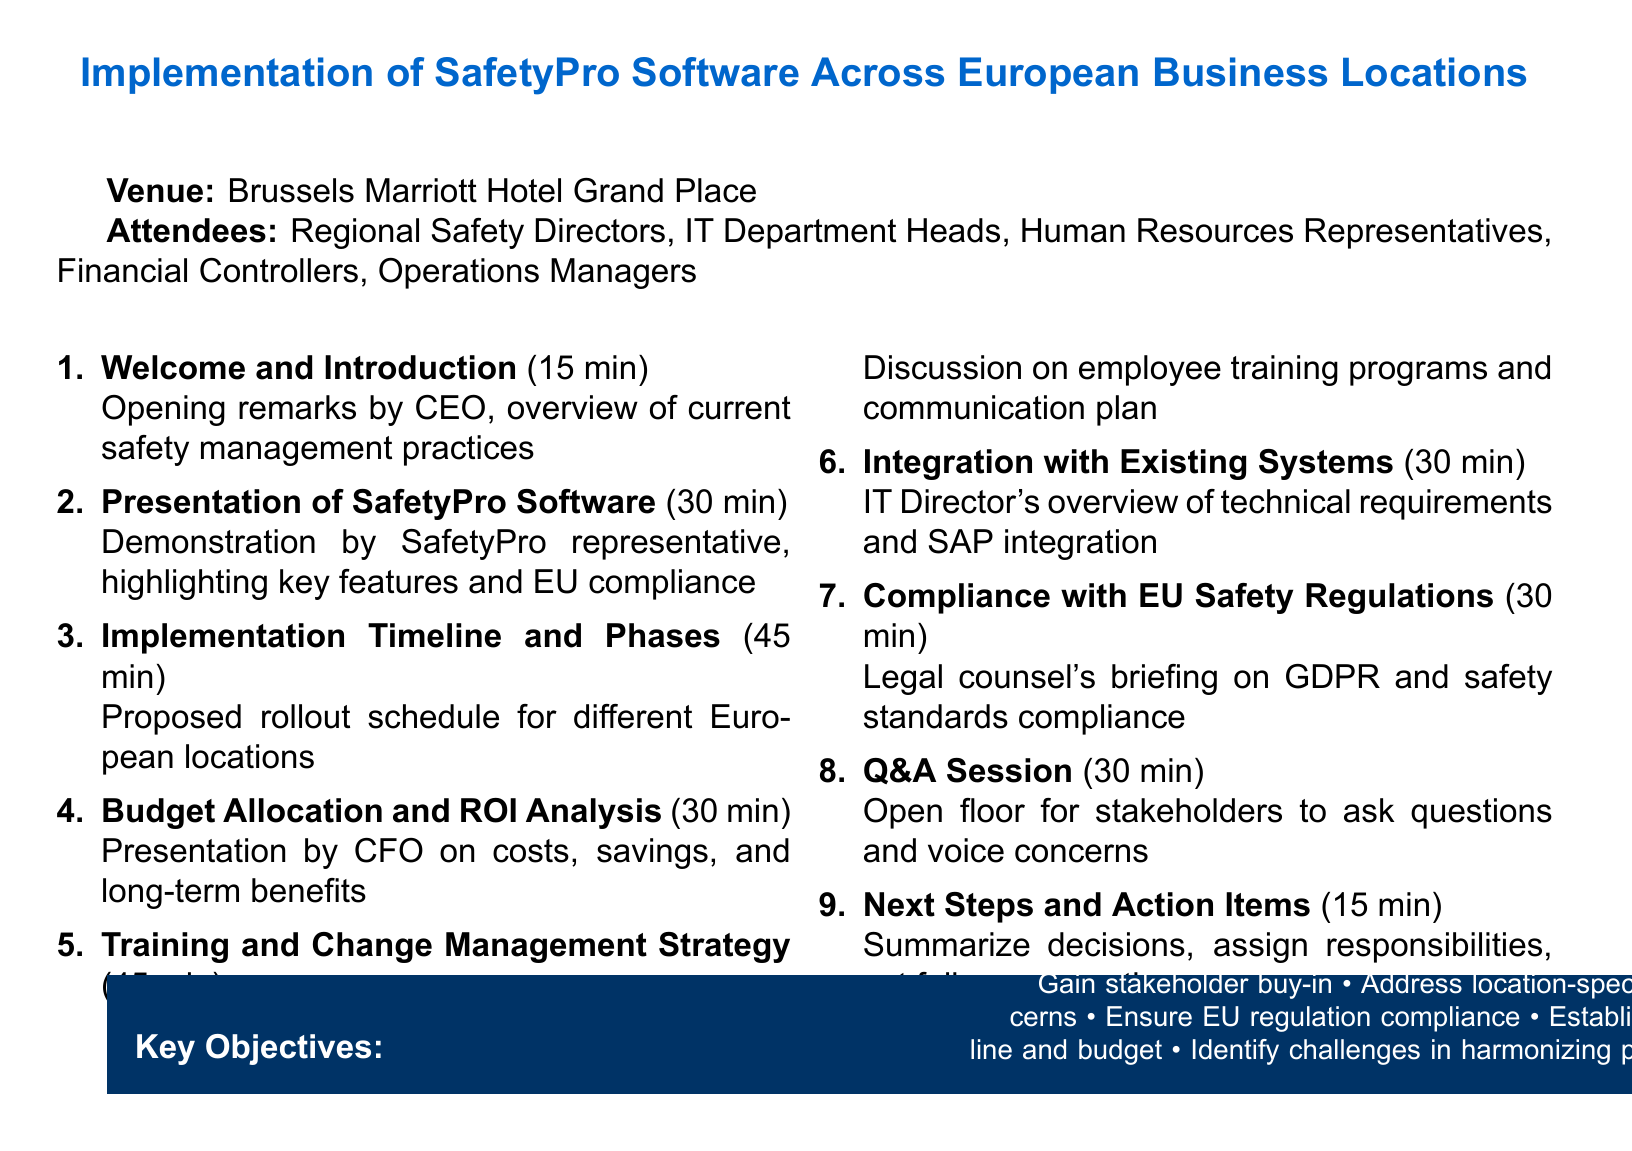What is the meeting title? The meeting title is specified in the document, indicating the main topic being discussed.
Answer: Stakeholder Meeting: Implementation of SafetyPro Software Across European Business Locations What is the date of the meeting? The date is explicitly mentioned in the document, providing a specific time for the event.
Answer: 15 June 2023 Where is the venue located? The venue's location is listed in the document, indicating where the meeting will be held.
Answer: Brussels Marriott Hotel Grand Place Who is responsible for the presentation of the SafetyPro Software? The document specifies who will lead the demo, giving clarity on responsibilities.
Answer: SafetyPro representative What is the duration for the Q&A Session? The document provides the time allocation for each agenda item, including this one.
Answer: 30 minutes How many minutes are allocated to the Training and Change Management Strategy? The document lists the duration for discussion on training and change management, providing clarity on time management.
Answer: 45 minutes What are the key objectives of the meeting? The document outlines the main goals, presenting a summary of what the meeting aims to achieve.
Answer: Gain stakeholder buy-in • Address location-specific concerns • Ensure EU regulation compliance • Establish timeline and budget • Identify challenges in harmonizing practices Who will lead the discussion on Budget Allocation and ROI Analysis? The agenda specifies who will present this topic, clarifying roles in the meeting.
Answer: CFO How many attendees are listed in the document? The document includes a list of attendees, which can indicate the level of involvement in the meeting.
Answer: Five 